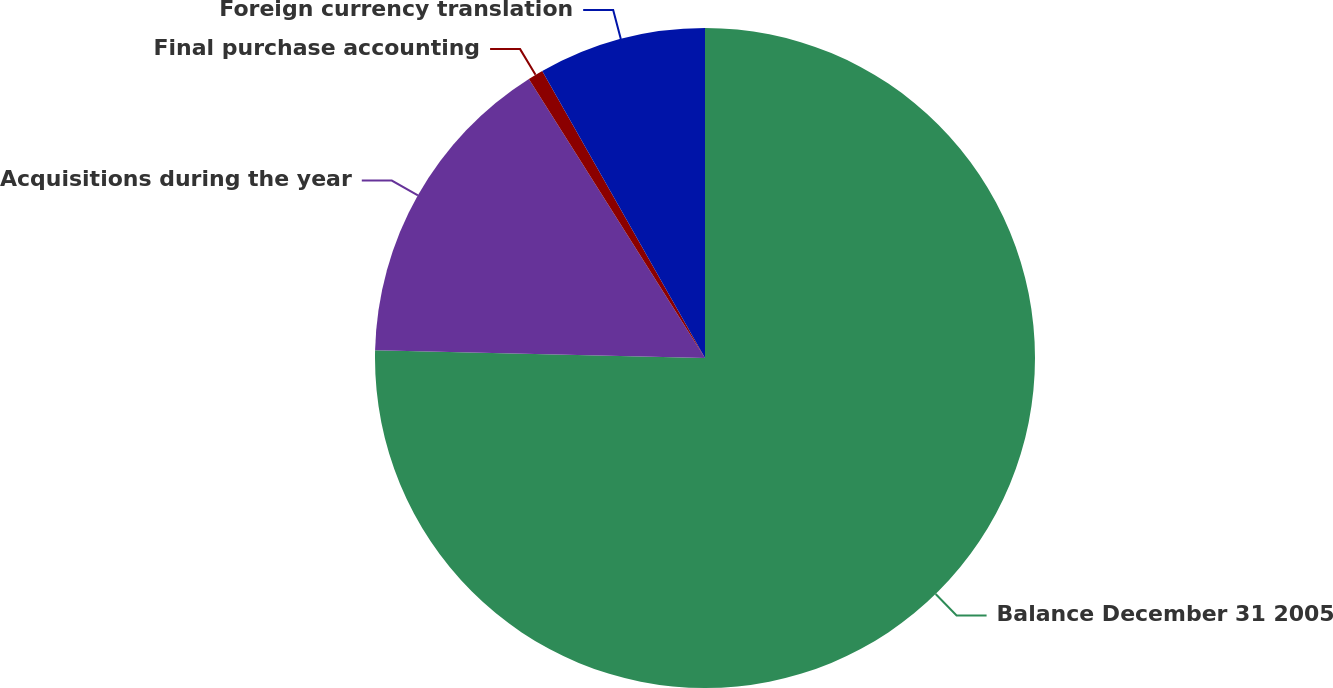Convert chart to OTSL. <chart><loc_0><loc_0><loc_500><loc_500><pie_chart><fcel>Balance December 31 2005<fcel>Acquisitions during the year<fcel>Final purchase accounting<fcel>Foreign currency translation<nl><fcel>75.37%<fcel>15.67%<fcel>0.75%<fcel>8.21%<nl></chart> 